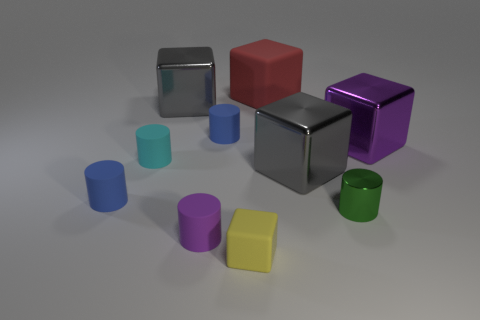How many metal blocks are the same size as the red matte thing?
Make the answer very short. 3. What is the size of the green cylinder?
Make the answer very short. Small. There is a red matte cube; what number of blocks are to the left of it?
Keep it short and to the point. 2. What is the shape of the purple thing that is the same material as the green thing?
Offer a terse response. Cube. Are there fewer small blue cylinders right of the cyan thing than tiny cyan things to the left of the yellow matte cube?
Make the answer very short. No. Is the number of cyan rubber cylinders greater than the number of large objects?
Offer a terse response. No. What is the large purple thing made of?
Give a very brief answer. Metal. There is a small cylinder behind the large purple shiny block; what is its color?
Provide a short and direct response. Blue. Are there more small blue things behind the small cyan rubber thing than yellow rubber blocks to the right of the yellow object?
Your response must be concise. Yes. There is a blue thing that is behind the blue cylinder left of the rubber cylinder behind the purple metallic cube; what size is it?
Your answer should be compact. Small. 